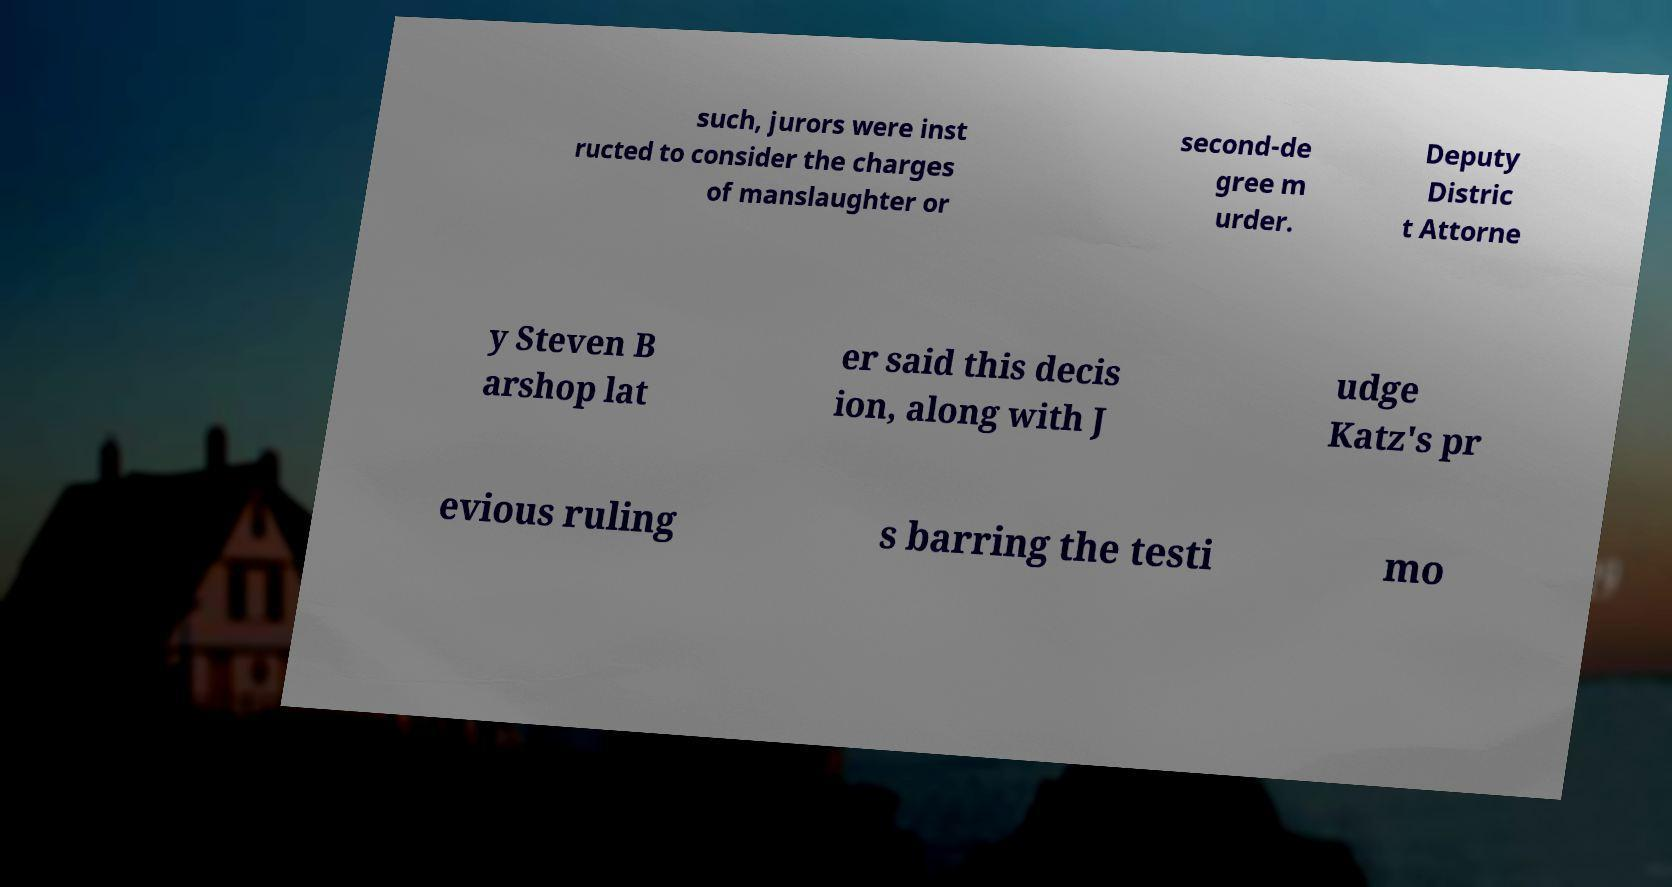Could you assist in decoding the text presented in this image and type it out clearly? such, jurors were inst ructed to consider the charges of manslaughter or second-de gree m urder. Deputy Distric t Attorne y Steven B arshop lat er said this decis ion, along with J udge Katz's pr evious ruling s barring the testi mo 